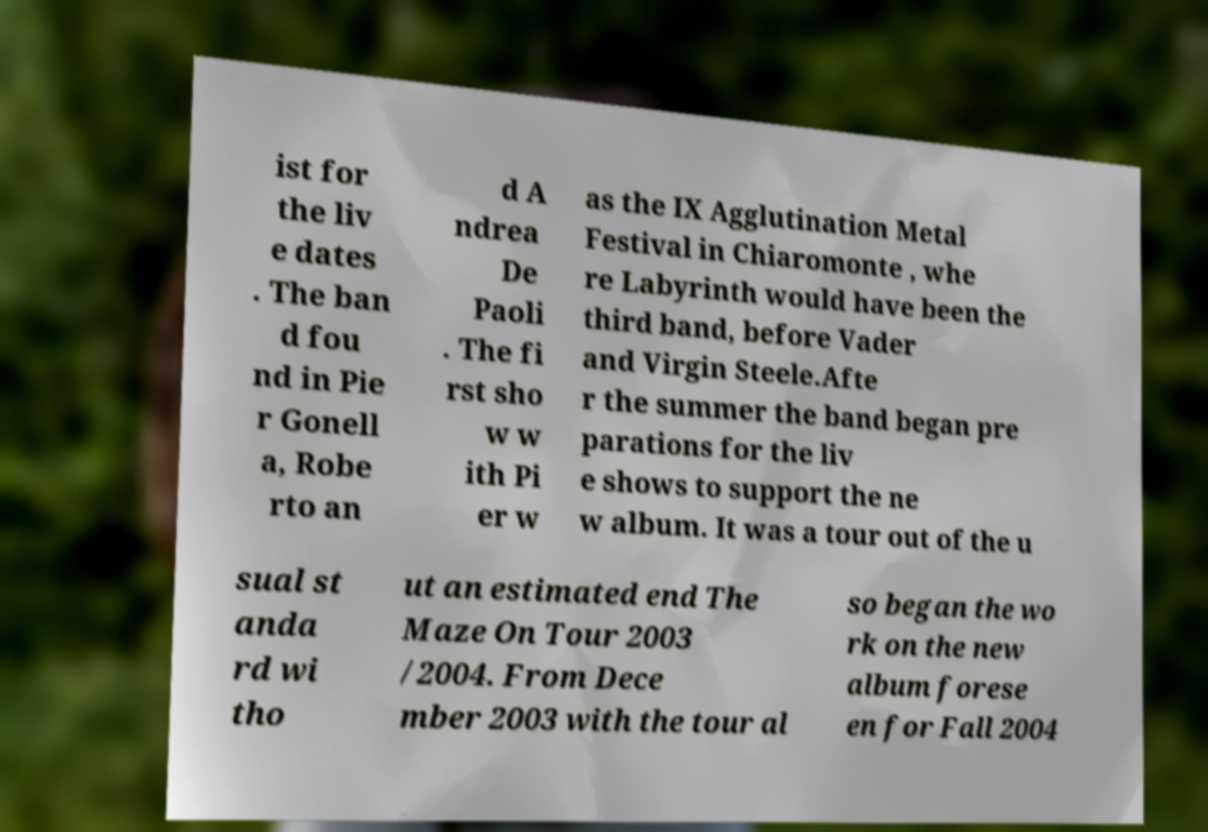Please identify and transcribe the text found in this image. ist for the liv e dates . The ban d fou nd in Pie r Gonell a, Robe rto an d A ndrea De Paoli . The fi rst sho w w ith Pi er w as the IX Agglutination Metal Festival in Chiaromonte , whe re Labyrinth would have been the third band, before Vader and Virgin Steele.Afte r the summer the band began pre parations for the liv e shows to support the ne w album. It was a tour out of the u sual st anda rd wi tho ut an estimated end The Maze On Tour 2003 /2004. From Dece mber 2003 with the tour al so began the wo rk on the new album forese en for Fall 2004 